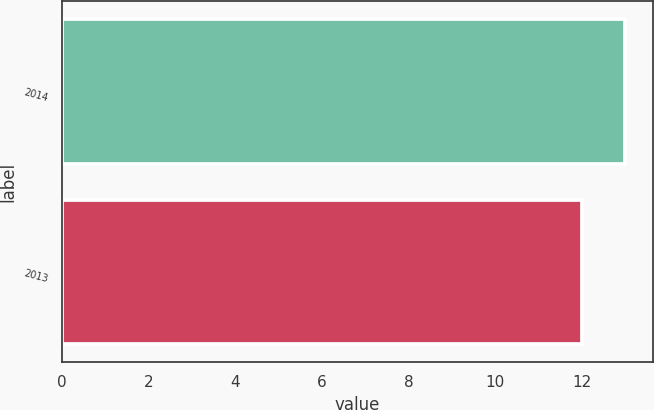<chart> <loc_0><loc_0><loc_500><loc_500><bar_chart><fcel>2014<fcel>2013<nl><fcel>13<fcel>12<nl></chart> 